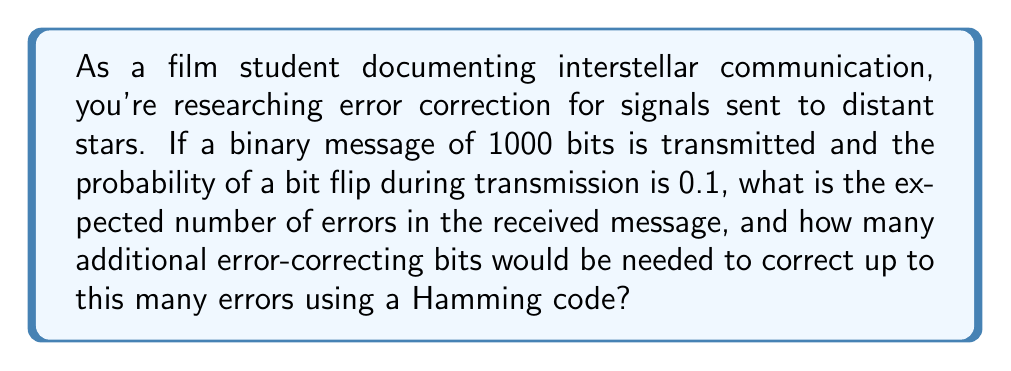Show me your answer to this math problem. To solve this problem, we'll follow these steps:

1. Calculate the expected number of errors:
   The number of errors in a binary transmission follows a binomial distribution. The expected value of a binomial distribution is $n * p$, where $n$ is the number of trials (bits) and $p$ is the probability of success (bit flip).

   Expected errors = $1000 * 0.1 = 100$ errors

2. Determine the number of error-correcting bits needed:
   Hamming codes can correct single-bit errors. To correct up to 100 errors, we need a code that can correct up to 100 single-bit errors. The number of data bits ($m$) and parity bits ($r$) in a Hamming code are related by the inequality:

   $$ 2^r \geq m + r + 1 $$

   Where $m = 1000$ (our original message length)

   We need to find the smallest $r$ that satisfies this inequality:

   $$ 2^r \geq 1000 + r + 1 $$

   Through trial and error or computational methods, we find that $r = 10$ is the smallest value that satisfies this inequality:

   $$ 2^{10} = 1024 \geq 1000 + 10 + 1 = 1011 $$

   Therefore, we need 10 additional error-correcting bits.

3. Verify the error-correcting capability:
   A Hamming code with $r$ parity bits can correct up to $2^{r-1} - 1$ errors. With $r = 10$:

   $$ 2^{10-1} - 1 = 2^9 - 1 = 512 - 1 = 511 $$

   This is indeed greater than the expected 100 errors, confirming that 10 parity bits are sufficient.
Answer: The expected number of errors is 100, and 10 additional error-correcting bits would be needed to correct up to this many errors using a Hamming code. 